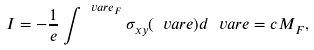Convert formula to latex. <formula><loc_0><loc_0><loc_500><loc_500>I = - \frac { 1 } { e } \int ^ { \ v a r e _ { F } } \sigma _ { x y } ( \ v a r e ) d \ v a r e = c M _ { F } ,</formula> 